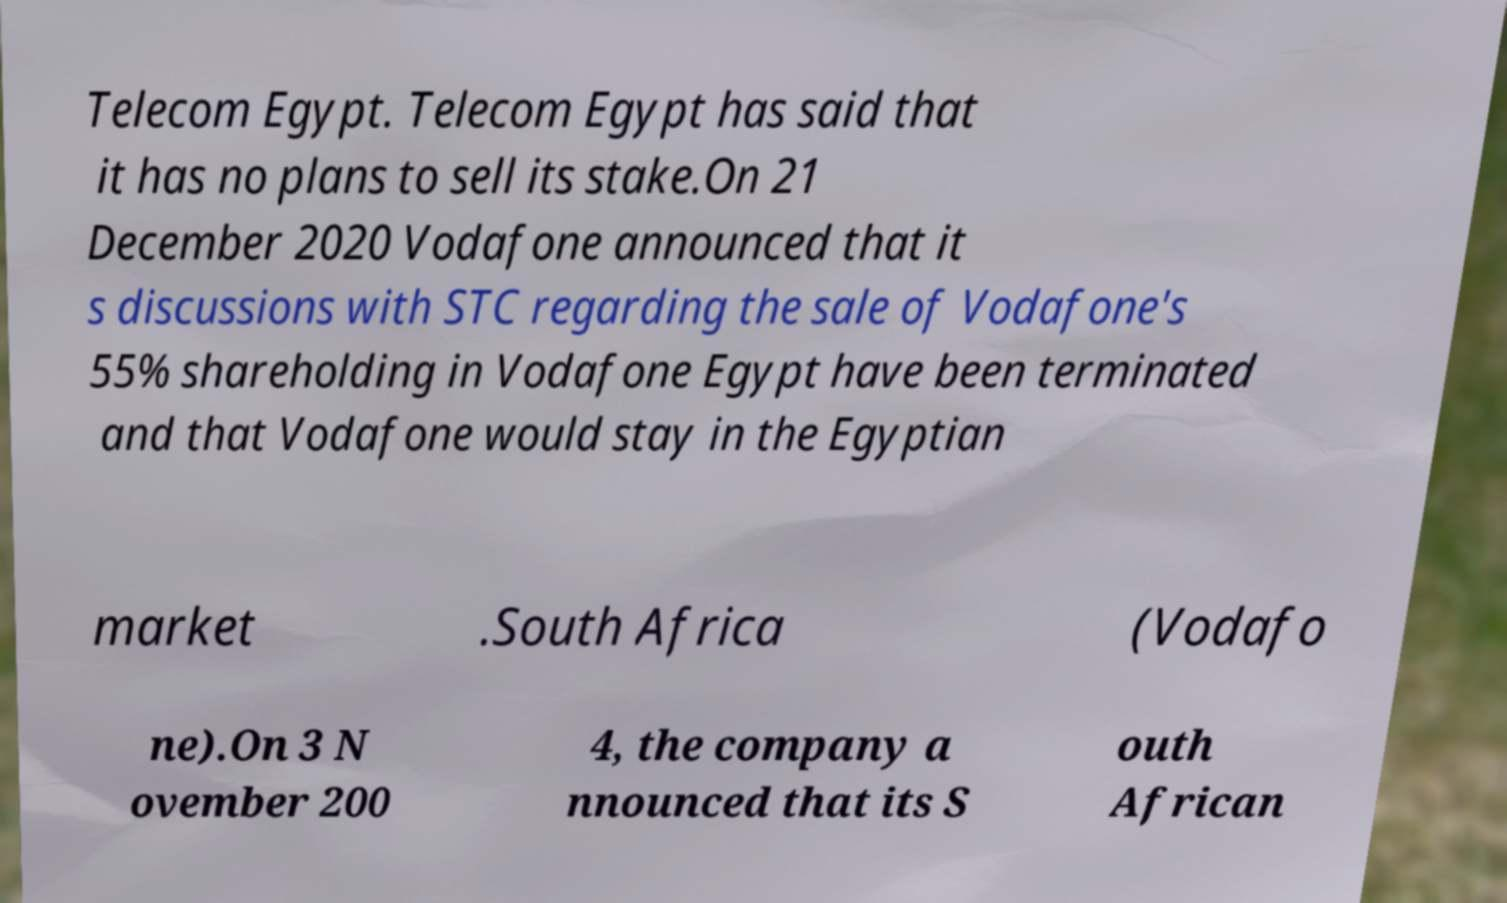What messages or text are displayed in this image? I need them in a readable, typed format. Telecom Egypt. Telecom Egypt has said that it has no plans to sell its stake.On 21 December 2020 Vodafone announced that it s discussions with STC regarding the sale of Vodafone's 55% shareholding in Vodafone Egypt have been terminated and that Vodafone would stay in the Egyptian market .South Africa (Vodafo ne).On 3 N ovember 200 4, the company a nnounced that its S outh African 